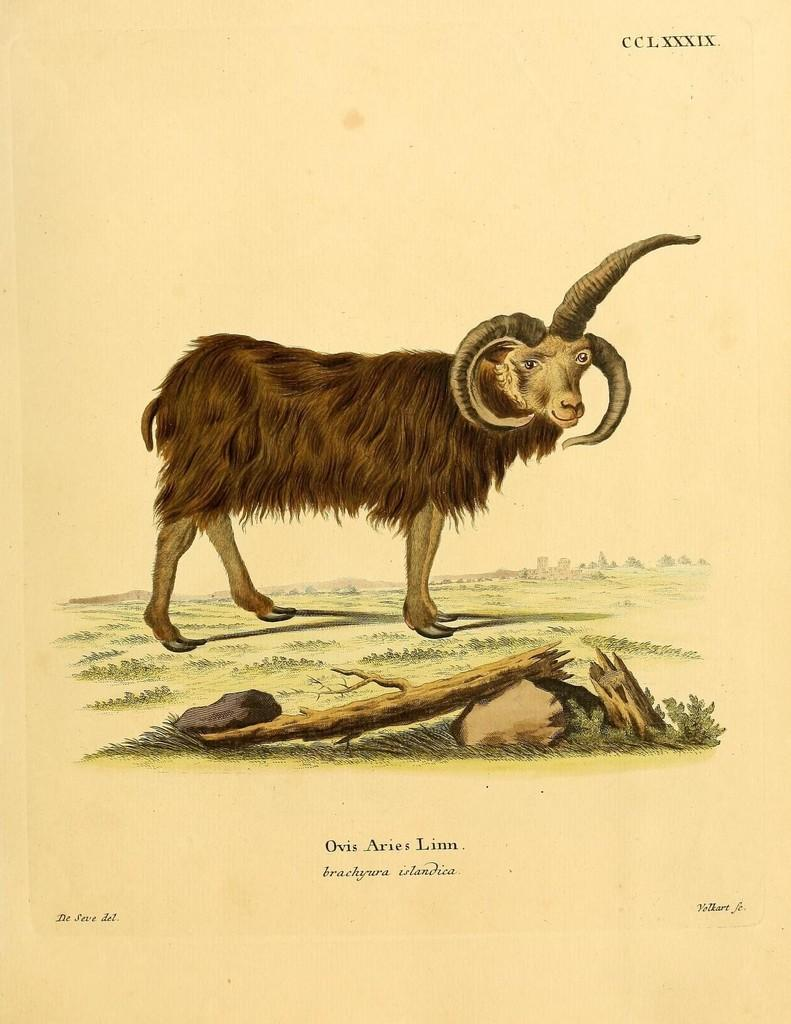What is depicted on the poster in the image? There is a poster of a sheep in the image. How many horns does the sheep on the poster have? The sheep on the poster has three horns. What type of natural elements can be seen in the image? There are stones, grass, and a tree visible in the image. What is the pole on the ground used for in the image? The purpose of the pole on the ground is not specified in the image. What type of brush is being used to groom the snake in the image? There is no snake or brush present in the image; it features a poster of a sheep with three horns. 